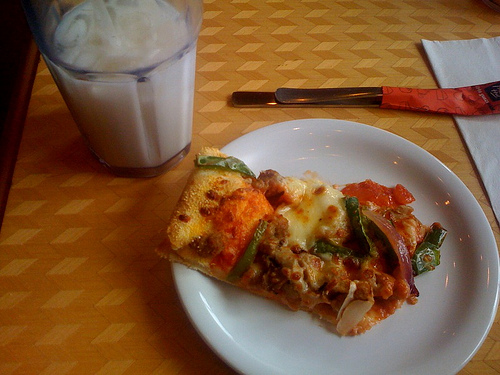<image>What cooking utensil can be seen on the table? I am not sure what cooking utensil can be seen on the table. It can be 'knife', 'fork' or both 'knife and fork'. What cooking utensil can be seen on the table? There is a knife and fork on the table. 